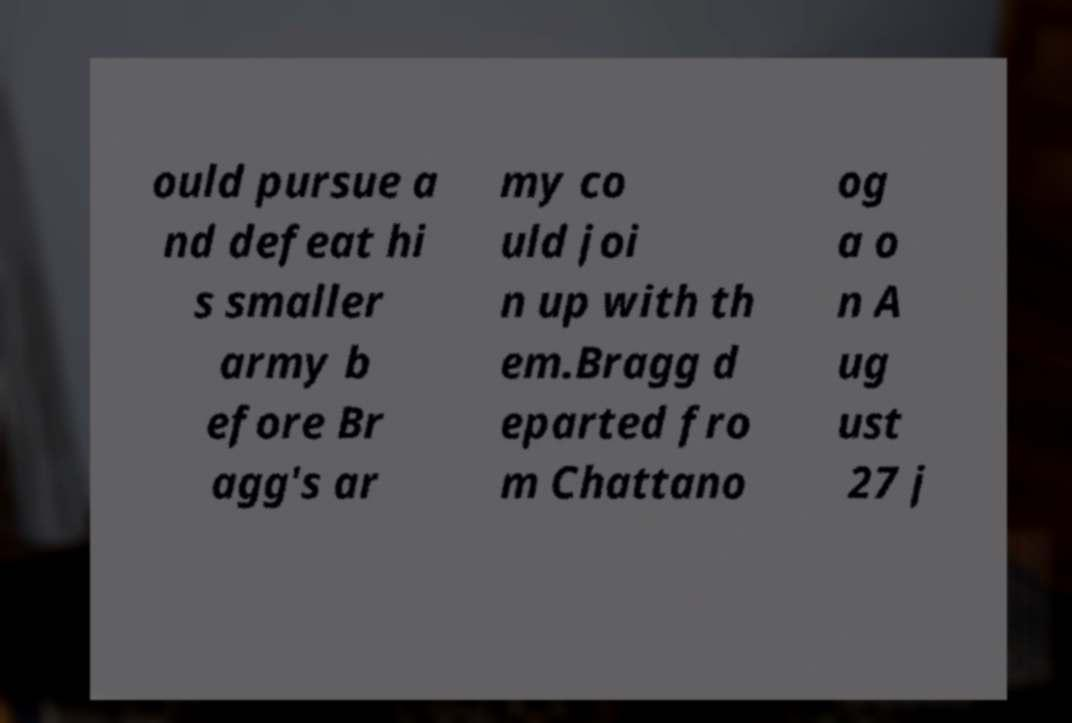Can you accurately transcribe the text from the provided image for me? ould pursue a nd defeat hi s smaller army b efore Br agg's ar my co uld joi n up with th em.Bragg d eparted fro m Chattano og a o n A ug ust 27 j 